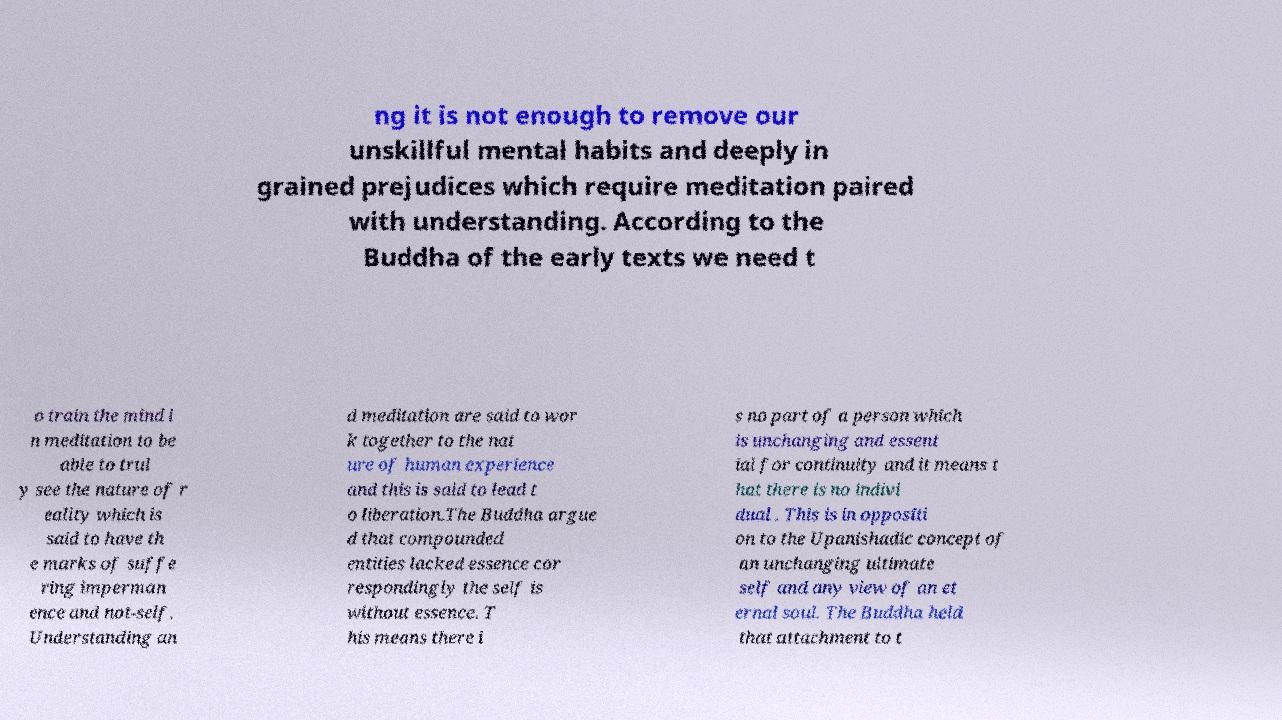Can you read and provide the text displayed in the image?This photo seems to have some interesting text. Can you extract and type it out for me? ng it is not enough to remove our unskillful mental habits and deeply in grained prejudices which require meditation paired with understanding. According to the Buddha of the early texts we need t o train the mind i n meditation to be able to trul y see the nature of r eality which is said to have th e marks of suffe ring imperman ence and not-self. Understanding an d meditation are said to wor k together to the nat ure of human experience and this is said to lead t o liberation.The Buddha argue d that compounded entities lacked essence cor respondingly the self is without essence. T his means there i s no part of a person which is unchanging and essent ial for continuity and it means t hat there is no indivi dual . This is in oppositi on to the Upanishadic concept of an unchanging ultimate self and any view of an et ernal soul. The Buddha held that attachment to t 